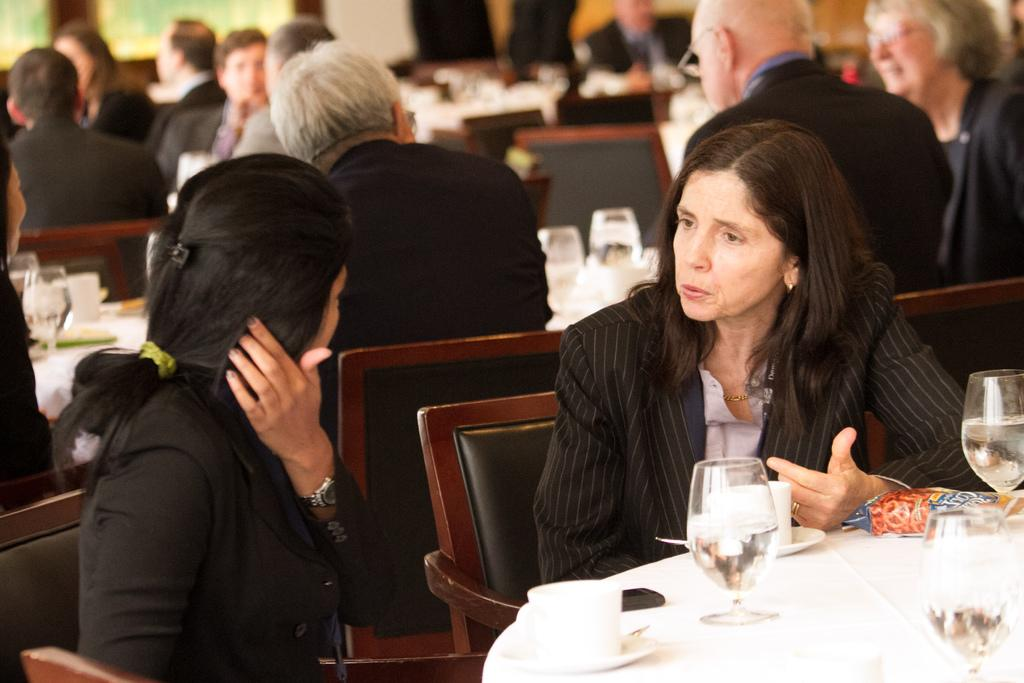How many women are sitting at the table in the image? There are two women sitting at a table in the image. What are the women doing at the table? The women are talking to each other. Can you describe the other people in the image? There are other people at different tables, and they are in groups. What are the people at different tables doing? The people at different tables are sitting and talking. Can you see any hens walking around the tables in the image? There are no hens present in the image. Are there any ants crawling on the table where the women are sitting? There is no indication of ants in the image. 